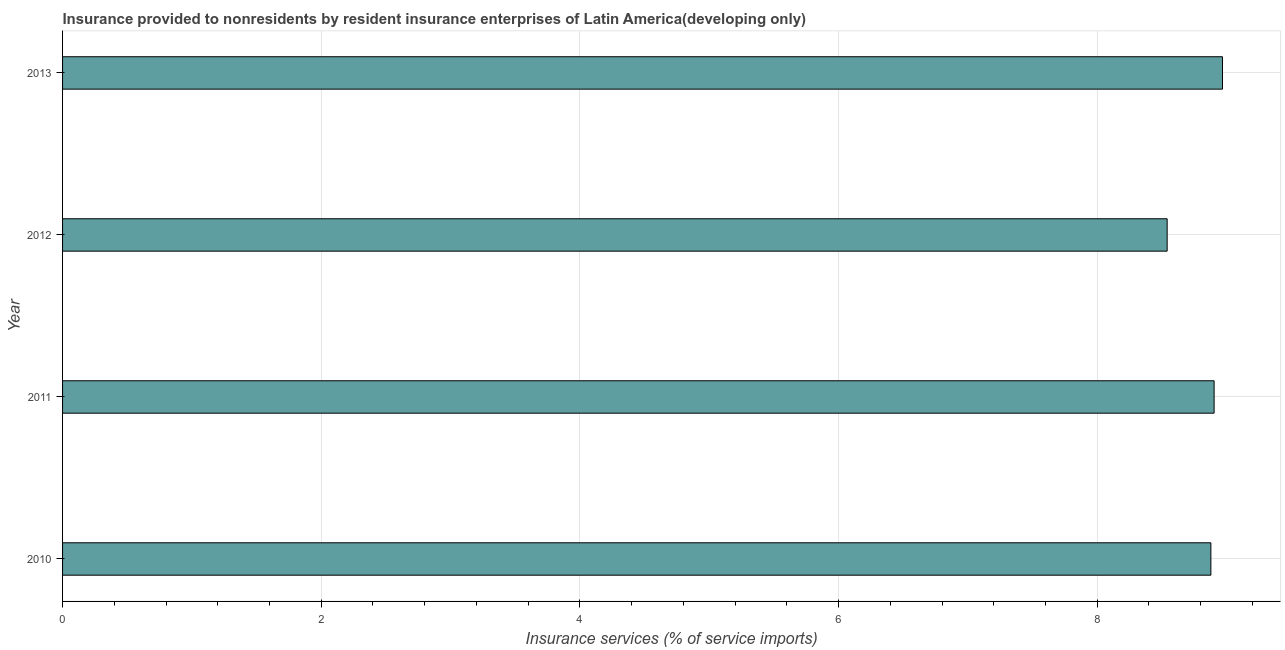Does the graph contain grids?
Make the answer very short. Yes. What is the title of the graph?
Provide a succinct answer. Insurance provided to nonresidents by resident insurance enterprises of Latin America(developing only). What is the label or title of the X-axis?
Provide a succinct answer. Insurance services (% of service imports). What is the insurance and financial services in 2012?
Offer a terse response. 8.54. Across all years, what is the maximum insurance and financial services?
Provide a short and direct response. 8.97. Across all years, what is the minimum insurance and financial services?
Your answer should be compact. 8.54. In which year was the insurance and financial services minimum?
Provide a succinct answer. 2012. What is the sum of the insurance and financial services?
Ensure brevity in your answer.  35.29. What is the difference between the insurance and financial services in 2012 and 2013?
Your answer should be very brief. -0.43. What is the average insurance and financial services per year?
Your answer should be compact. 8.82. What is the median insurance and financial services?
Your answer should be compact. 8.89. In how many years, is the insurance and financial services greater than 2 %?
Provide a succinct answer. 4. Do a majority of the years between 2010 and 2012 (inclusive) have insurance and financial services greater than 7.6 %?
Your answer should be compact. Yes. Is the insurance and financial services in 2011 less than that in 2012?
Keep it short and to the point. No. What is the difference between the highest and the second highest insurance and financial services?
Offer a very short reply. 0.07. What is the difference between the highest and the lowest insurance and financial services?
Provide a short and direct response. 0.43. How many bars are there?
Provide a succinct answer. 4. Are all the bars in the graph horizontal?
Provide a succinct answer. Yes. What is the Insurance services (% of service imports) in 2010?
Make the answer very short. 8.88. What is the Insurance services (% of service imports) of 2011?
Your answer should be very brief. 8.9. What is the Insurance services (% of service imports) in 2012?
Your answer should be compact. 8.54. What is the Insurance services (% of service imports) in 2013?
Your answer should be compact. 8.97. What is the difference between the Insurance services (% of service imports) in 2010 and 2011?
Provide a short and direct response. -0.02. What is the difference between the Insurance services (% of service imports) in 2010 and 2012?
Your response must be concise. 0.34. What is the difference between the Insurance services (% of service imports) in 2010 and 2013?
Your answer should be very brief. -0.09. What is the difference between the Insurance services (% of service imports) in 2011 and 2012?
Offer a very short reply. 0.36. What is the difference between the Insurance services (% of service imports) in 2011 and 2013?
Keep it short and to the point. -0.06. What is the difference between the Insurance services (% of service imports) in 2012 and 2013?
Ensure brevity in your answer.  -0.43. What is the ratio of the Insurance services (% of service imports) in 2010 to that in 2013?
Your answer should be compact. 0.99. What is the ratio of the Insurance services (% of service imports) in 2011 to that in 2012?
Your answer should be compact. 1.04. What is the ratio of the Insurance services (% of service imports) in 2011 to that in 2013?
Make the answer very short. 0.99. What is the ratio of the Insurance services (% of service imports) in 2012 to that in 2013?
Your answer should be compact. 0.95. 